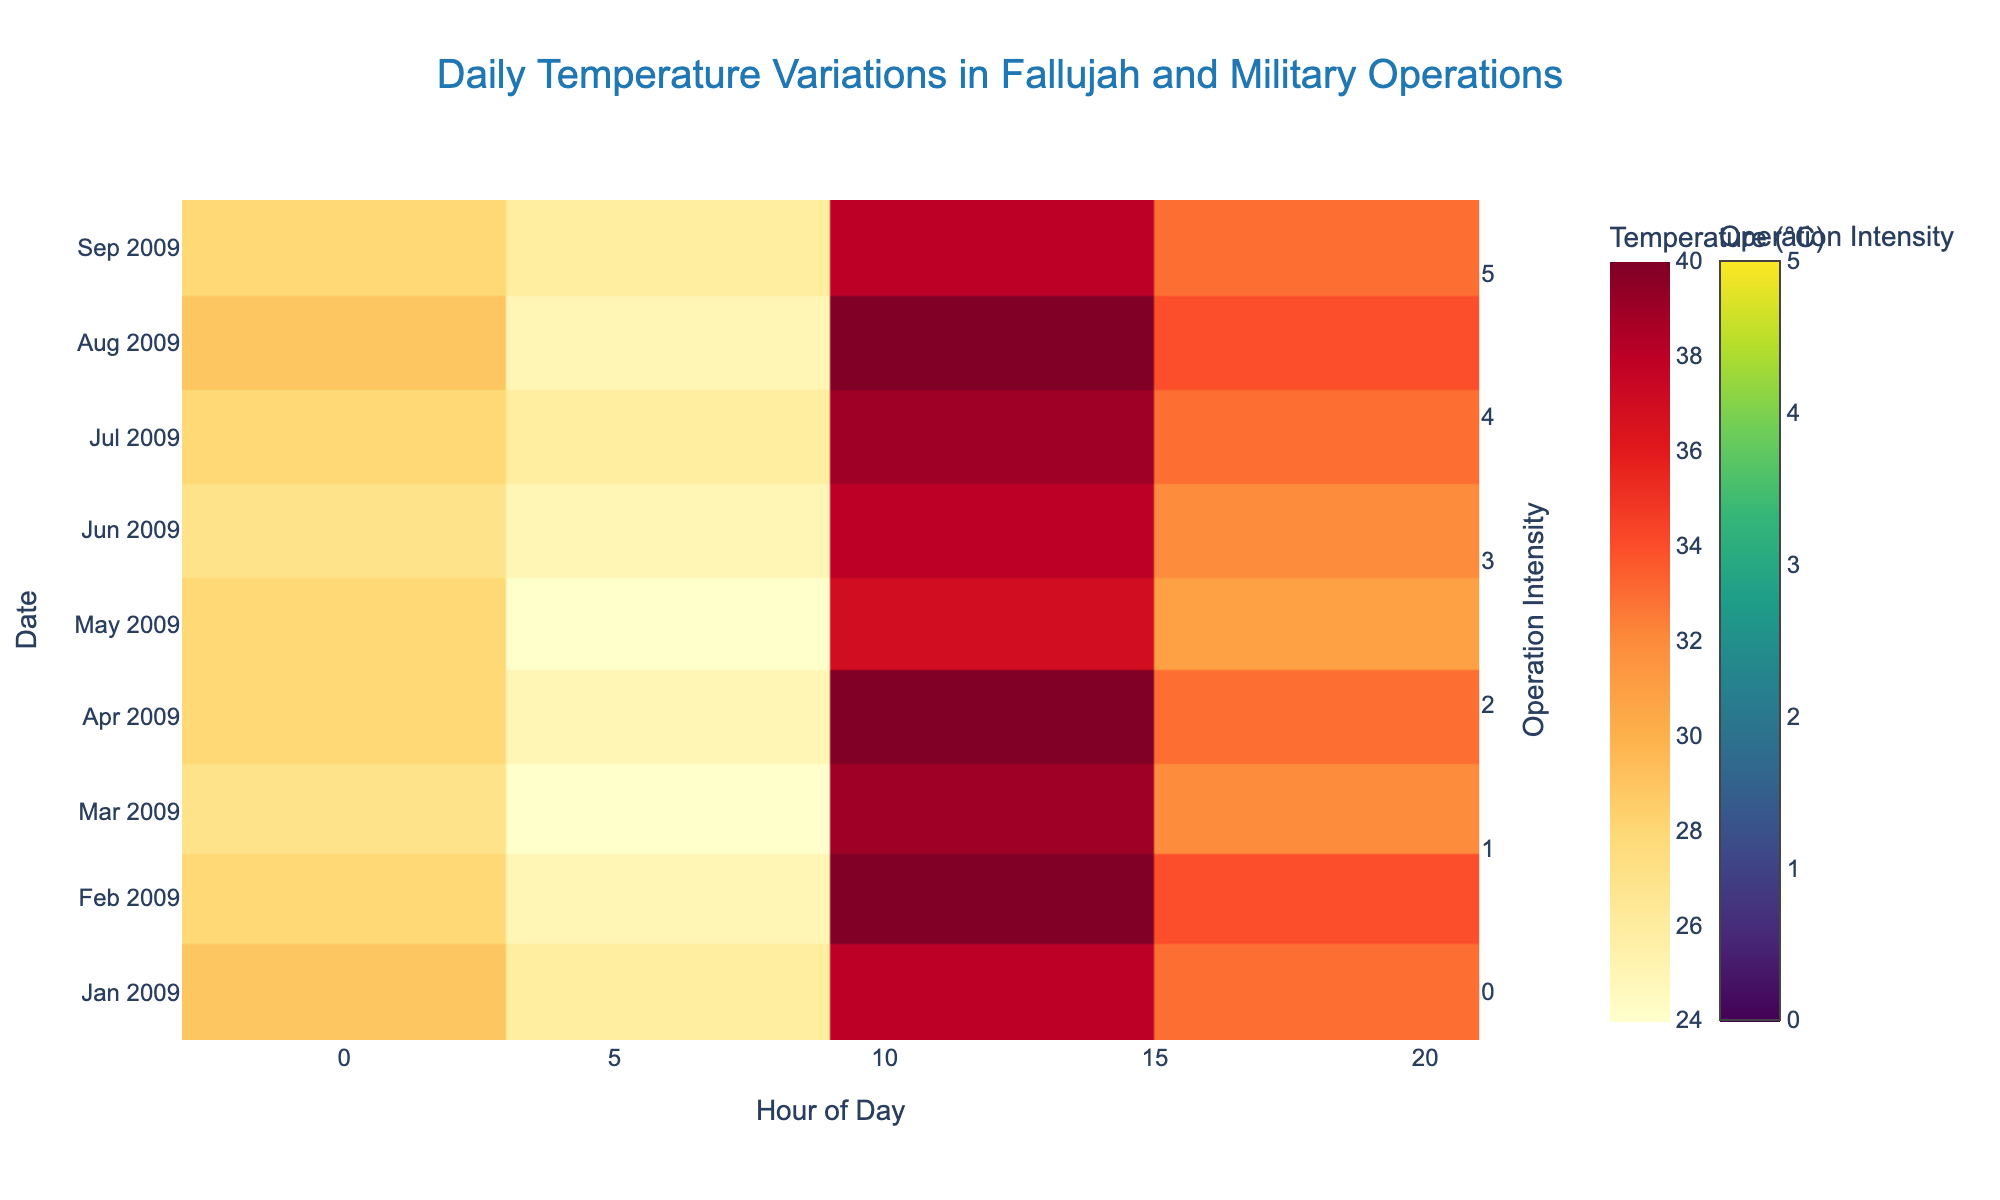What is the title of the figure? The title is located at the top center of the figure. Observing the figure, the title is clearly written there.
Answer: Daily Temperature Variations in Fallujah and Military Operations Which day recorded the highest temperature at 12:00? To find the answer, look at the hours on the x-axis and find the 12:00 time slot. Then look down at the color scale on the heatmap to identify the day with the darkest red color, indicating the highest temperature.
Answer: September 2 and September 4 How does the intensity of military operations vary across the days? By examining the scatter plot markers overlaid on the heatmap, which vary in size and color, we can determine that larger and darker markers indicate higher intensity. Observing several days, some like September 2 and September 5 have markers indicating higher intensity operations.
Answer: It varies, with higher intensities on September 2 and September 5 Compare the temperatures between 06:00 and 12:00 on September 1. Which is higher? Look at the color of the heatmap for September 1 at the hourly slots of 06:00 and 12:00. Darker colors represent higher temperatures. By comparing these slots, the color indicates that the temperature at 12:00 is higher.
Answer: 12:00 What is the average temperature recorded at 18:00 across the days? To find this, sum up all the temperatures recorded at 18:00 from each day and then divide by the total number of days. From the data, the temperatures at 18:00 on each day are: 33, 34, 32, 33, 31, 32, 33, 34, 33. Summing them up: 33 + 34 + 32 + 33 + 31 + 32 + 33 + 34 + 33 = 295, and there are 9 days. So the average is 295/9.
Answer: 32.78 On which date did the temperature not change between 00:00 and 06:00? Examine the color intensity for a given day at the time slots 00:00 and 06:00. A day where the color does not change between these two times will have similar values. Observing the heatmap, we can see for September 5.
Answer: September 5 Which hour of the day generally has the highest temperatures? By observing the heatmap and associated colors corresponding to each hour of the day across the dates, note which hour consistently shows the darkest red colors (highest temperatures).
Answer: 12:00 How do the military operations correlate with the temperature variations? Observing the scatter plot markers and their colors/intensity over the heatmap, notice the patterns if intense operations align with any particular temperature patterns or differences. Operations seem to be more frequent or intense during higher temperature times, especially near noon (12:00).
Answer: Markerge towards higher temperatures around 12:00 What is the temperature trend from 00:00 to 18:00 on September 3? Trace the temperature colors from 00:00, 06:00, 12:00, and 18:00 for September 3. The temperature starts cooler (28°C), drops slightly (24°C), rises significantly by noon (39°C), and then lowers slightly by 18:00 (32°C).
Answer: Cooler at 00:00, drops at 06:00, peaks at 12:00, and lowers at 18:00 